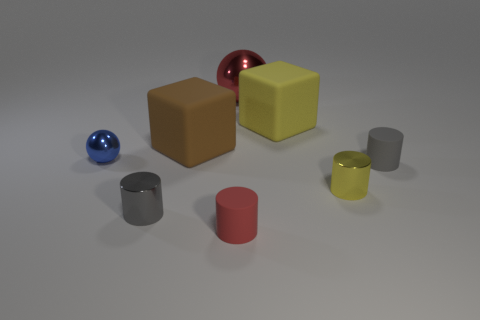Add 2 tiny green blocks. How many objects exist? 10 Subtract all yellow cylinders. How many cylinders are left? 3 Subtract all spheres. How many objects are left? 6 Add 4 small yellow rubber cubes. How many small yellow rubber cubes exist? 4 Subtract 0 gray spheres. How many objects are left? 8 Subtract 1 spheres. How many spheres are left? 1 Subtract all green cylinders. Subtract all red balls. How many cylinders are left? 4 Subtract all blue cubes. How many brown cylinders are left? 0 Subtract all large brown objects. Subtract all blue things. How many objects are left? 6 Add 3 tiny metal objects. How many tiny metal objects are left? 6 